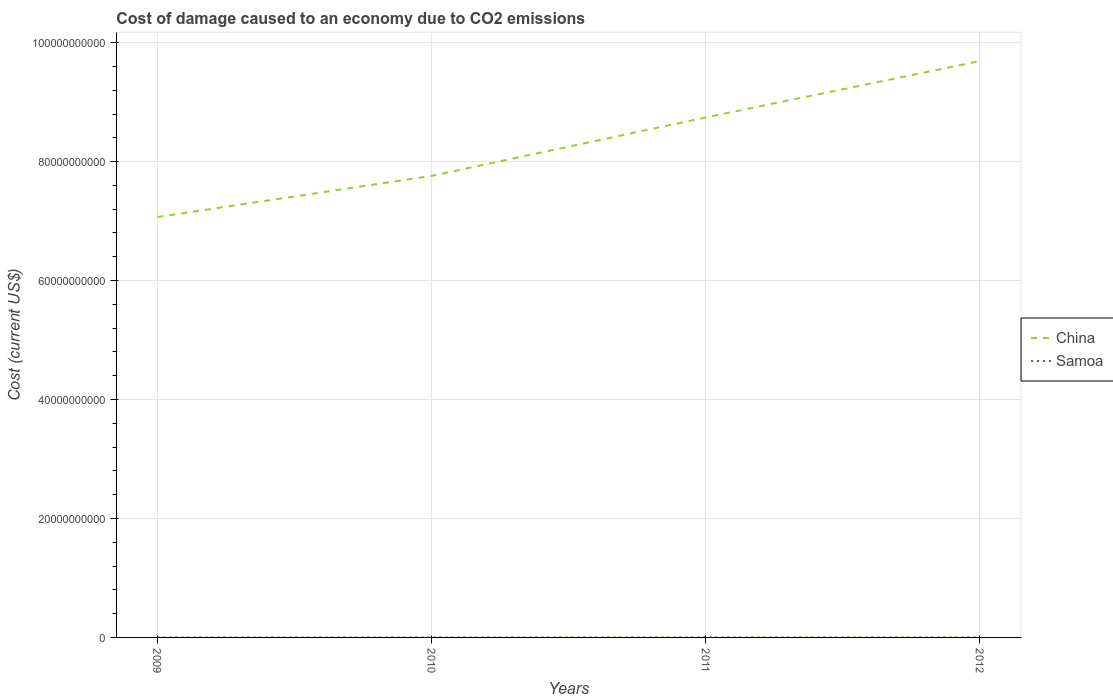How many different coloured lines are there?
Make the answer very short. 2. Does the line corresponding to Samoa intersect with the line corresponding to China?
Your answer should be very brief. No. Across all years, what is the maximum cost of damage caused due to CO2 emissisons in China?
Your answer should be very brief. 7.07e+1. What is the total cost of damage caused due to CO2 emissisons in China in the graph?
Your answer should be very brief. -1.67e+1. What is the difference between the highest and the second highest cost of damage caused due to CO2 emissisons in Samoa?
Make the answer very short. 5.30e+05. What is the difference between two consecutive major ticks on the Y-axis?
Provide a succinct answer. 2.00e+1. Does the graph contain any zero values?
Your answer should be very brief. No. What is the title of the graph?
Offer a very short reply. Cost of damage caused to an economy due to CO2 emissions. Does "Palau" appear as one of the legend labels in the graph?
Provide a short and direct response. No. What is the label or title of the Y-axis?
Your answer should be very brief. Cost (current US$). What is the Cost (current US$) in China in 2009?
Give a very brief answer. 7.07e+1. What is the Cost (current US$) of Samoa in 2009?
Your answer should be very brief. 1.82e+06. What is the Cost (current US$) in China in 2010?
Offer a terse response. 7.76e+1. What is the Cost (current US$) in Samoa in 2010?
Provide a succinct answer. 1.93e+06. What is the Cost (current US$) in China in 2011?
Keep it short and to the point. 8.74e+1. What is the Cost (current US$) in Samoa in 2011?
Make the answer very short. 2.27e+06. What is the Cost (current US$) of China in 2012?
Provide a succinct answer. 9.69e+1. What is the Cost (current US$) of Samoa in 2012?
Your answer should be very brief. 2.35e+06. Across all years, what is the maximum Cost (current US$) of China?
Offer a very short reply. 9.69e+1. Across all years, what is the maximum Cost (current US$) of Samoa?
Provide a succinct answer. 2.35e+06. Across all years, what is the minimum Cost (current US$) in China?
Your response must be concise. 7.07e+1. Across all years, what is the minimum Cost (current US$) in Samoa?
Offer a very short reply. 1.82e+06. What is the total Cost (current US$) in China in the graph?
Provide a short and direct response. 3.33e+11. What is the total Cost (current US$) of Samoa in the graph?
Provide a short and direct response. 8.37e+06. What is the difference between the Cost (current US$) of China in 2009 and that in 2010?
Provide a short and direct response. -6.92e+09. What is the difference between the Cost (current US$) of Samoa in 2009 and that in 2010?
Ensure brevity in your answer.  -1.11e+05. What is the difference between the Cost (current US$) of China in 2009 and that in 2011?
Your response must be concise. -1.67e+1. What is the difference between the Cost (current US$) in Samoa in 2009 and that in 2011?
Give a very brief answer. -4.55e+05. What is the difference between the Cost (current US$) of China in 2009 and that in 2012?
Offer a very short reply. -2.62e+1. What is the difference between the Cost (current US$) of Samoa in 2009 and that in 2012?
Your response must be concise. -5.30e+05. What is the difference between the Cost (current US$) in China in 2010 and that in 2011?
Make the answer very short. -9.83e+09. What is the difference between the Cost (current US$) in Samoa in 2010 and that in 2011?
Keep it short and to the point. -3.45e+05. What is the difference between the Cost (current US$) of China in 2010 and that in 2012?
Keep it short and to the point. -1.93e+1. What is the difference between the Cost (current US$) of Samoa in 2010 and that in 2012?
Provide a short and direct response. -4.20e+05. What is the difference between the Cost (current US$) of China in 2011 and that in 2012?
Give a very brief answer. -9.48e+09. What is the difference between the Cost (current US$) of Samoa in 2011 and that in 2012?
Offer a terse response. -7.48e+04. What is the difference between the Cost (current US$) of China in 2009 and the Cost (current US$) of Samoa in 2010?
Your answer should be compact. 7.07e+1. What is the difference between the Cost (current US$) in China in 2009 and the Cost (current US$) in Samoa in 2011?
Your answer should be compact. 7.07e+1. What is the difference between the Cost (current US$) in China in 2009 and the Cost (current US$) in Samoa in 2012?
Your answer should be compact. 7.07e+1. What is the difference between the Cost (current US$) of China in 2010 and the Cost (current US$) of Samoa in 2011?
Ensure brevity in your answer.  7.76e+1. What is the difference between the Cost (current US$) of China in 2010 and the Cost (current US$) of Samoa in 2012?
Your response must be concise. 7.76e+1. What is the difference between the Cost (current US$) of China in 2011 and the Cost (current US$) of Samoa in 2012?
Provide a short and direct response. 8.74e+1. What is the average Cost (current US$) of China per year?
Your response must be concise. 8.31e+1. What is the average Cost (current US$) in Samoa per year?
Provide a succinct answer. 2.09e+06. In the year 2009, what is the difference between the Cost (current US$) of China and Cost (current US$) of Samoa?
Your response must be concise. 7.07e+1. In the year 2010, what is the difference between the Cost (current US$) of China and Cost (current US$) of Samoa?
Make the answer very short. 7.76e+1. In the year 2011, what is the difference between the Cost (current US$) in China and Cost (current US$) in Samoa?
Make the answer very short. 8.74e+1. In the year 2012, what is the difference between the Cost (current US$) in China and Cost (current US$) in Samoa?
Make the answer very short. 9.69e+1. What is the ratio of the Cost (current US$) in China in 2009 to that in 2010?
Offer a terse response. 0.91. What is the ratio of the Cost (current US$) of Samoa in 2009 to that in 2010?
Give a very brief answer. 0.94. What is the ratio of the Cost (current US$) in China in 2009 to that in 2011?
Provide a succinct answer. 0.81. What is the ratio of the Cost (current US$) of Samoa in 2009 to that in 2011?
Offer a very short reply. 0.8. What is the ratio of the Cost (current US$) in China in 2009 to that in 2012?
Provide a short and direct response. 0.73. What is the ratio of the Cost (current US$) in Samoa in 2009 to that in 2012?
Give a very brief answer. 0.77. What is the ratio of the Cost (current US$) of China in 2010 to that in 2011?
Offer a terse response. 0.89. What is the ratio of the Cost (current US$) of Samoa in 2010 to that in 2011?
Your answer should be compact. 0.85. What is the ratio of the Cost (current US$) in China in 2010 to that in 2012?
Provide a succinct answer. 0.8. What is the ratio of the Cost (current US$) in Samoa in 2010 to that in 2012?
Keep it short and to the point. 0.82. What is the ratio of the Cost (current US$) of China in 2011 to that in 2012?
Your response must be concise. 0.9. What is the ratio of the Cost (current US$) in Samoa in 2011 to that in 2012?
Ensure brevity in your answer.  0.97. What is the difference between the highest and the second highest Cost (current US$) of China?
Your answer should be very brief. 9.48e+09. What is the difference between the highest and the second highest Cost (current US$) in Samoa?
Provide a short and direct response. 7.48e+04. What is the difference between the highest and the lowest Cost (current US$) in China?
Ensure brevity in your answer.  2.62e+1. What is the difference between the highest and the lowest Cost (current US$) in Samoa?
Provide a short and direct response. 5.30e+05. 